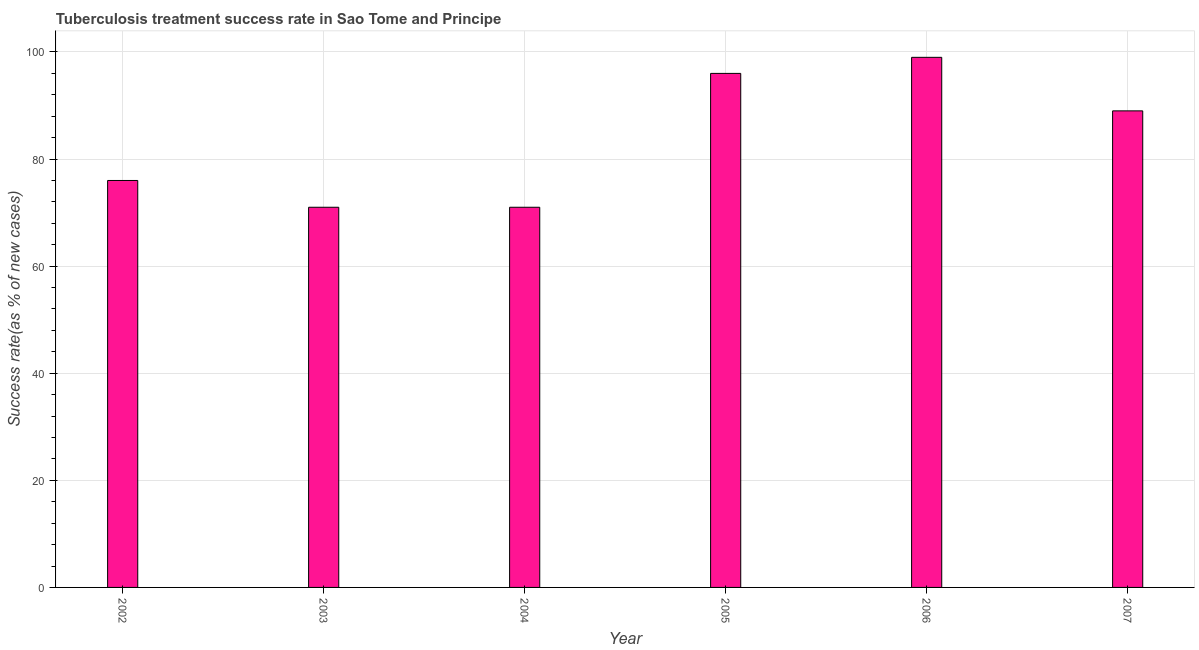What is the title of the graph?
Offer a terse response. Tuberculosis treatment success rate in Sao Tome and Principe. What is the label or title of the X-axis?
Provide a short and direct response. Year. What is the label or title of the Y-axis?
Your answer should be compact. Success rate(as % of new cases). In which year was the tuberculosis treatment success rate minimum?
Provide a short and direct response. 2003. What is the sum of the tuberculosis treatment success rate?
Ensure brevity in your answer.  502. What is the difference between the tuberculosis treatment success rate in 2002 and 2006?
Your answer should be compact. -23. What is the median tuberculosis treatment success rate?
Provide a succinct answer. 82.5. In how many years, is the tuberculosis treatment success rate greater than 60 %?
Your answer should be very brief. 6. Do a majority of the years between 2002 and 2003 (inclusive) have tuberculosis treatment success rate greater than 8 %?
Your answer should be very brief. Yes. What is the ratio of the tuberculosis treatment success rate in 2004 to that in 2007?
Your answer should be compact. 0.8. Is the tuberculosis treatment success rate in 2005 less than that in 2006?
Provide a succinct answer. Yes. Is the sum of the tuberculosis treatment success rate in 2003 and 2004 greater than the maximum tuberculosis treatment success rate across all years?
Make the answer very short. Yes. What is the difference between the highest and the lowest tuberculosis treatment success rate?
Your answer should be compact. 28. What is the difference between two consecutive major ticks on the Y-axis?
Ensure brevity in your answer.  20. Are the values on the major ticks of Y-axis written in scientific E-notation?
Give a very brief answer. No. What is the Success rate(as % of new cases) in 2002?
Give a very brief answer. 76. What is the Success rate(as % of new cases) of 2003?
Your response must be concise. 71. What is the Success rate(as % of new cases) of 2004?
Keep it short and to the point. 71. What is the Success rate(as % of new cases) in 2005?
Ensure brevity in your answer.  96. What is the Success rate(as % of new cases) of 2006?
Offer a very short reply. 99. What is the Success rate(as % of new cases) in 2007?
Ensure brevity in your answer.  89. What is the difference between the Success rate(as % of new cases) in 2002 and 2004?
Offer a terse response. 5. What is the difference between the Success rate(as % of new cases) in 2002 and 2005?
Your response must be concise. -20. What is the difference between the Success rate(as % of new cases) in 2003 and 2004?
Offer a very short reply. 0. What is the difference between the Success rate(as % of new cases) in 2003 and 2005?
Give a very brief answer. -25. What is the difference between the Success rate(as % of new cases) in 2003 and 2006?
Ensure brevity in your answer.  -28. What is the difference between the Success rate(as % of new cases) in 2003 and 2007?
Make the answer very short. -18. What is the difference between the Success rate(as % of new cases) in 2004 and 2005?
Your answer should be very brief. -25. What is the difference between the Success rate(as % of new cases) in 2004 and 2006?
Your answer should be compact. -28. What is the ratio of the Success rate(as % of new cases) in 2002 to that in 2003?
Your answer should be compact. 1.07. What is the ratio of the Success rate(as % of new cases) in 2002 to that in 2004?
Ensure brevity in your answer.  1.07. What is the ratio of the Success rate(as % of new cases) in 2002 to that in 2005?
Your answer should be very brief. 0.79. What is the ratio of the Success rate(as % of new cases) in 2002 to that in 2006?
Keep it short and to the point. 0.77. What is the ratio of the Success rate(as % of new cases) in 2002 to that in 2007?
Your answer should be very brief. 0.85. What is the ratio of the Success rate(as % of new cases) in 2003 to that in 2004?
Offer a very short reply. 1. What is the ratio of the Success rate(as % of new cases) in 2003 to that in 2005?
Make the answer very short. 0.74. What is the ratio of the Success rate(as % of new cases) in 2003 to that in 2006?
Your answer should be very brief. 0.72. What is the ratio of the Success rate(as % of new cases) in 2003 to that in 2007?
Your response must be concise. 0.8. What is the ratio of the Success rate(as % of new cases) in 2004 to that in 2005?
Your answer should be compact. 0.74. What is the ratio of the Success rate(as % of new cases) in 2004 to that in 2006?
Your answer should be compact. 0.72. What is the ratio of the Success rate(as % of new cases) in 2004 to that in 2007?
Your response must be concise. 0.8. What is the ratio of the Success rate(as % of new cases) in 2005 to that in 2007?
Offer a very short reply. 1.08. What is the ratio of the Success rate(as % of new cases) in 2006 to that in 2007?
Your response must be concise. 1.11. 